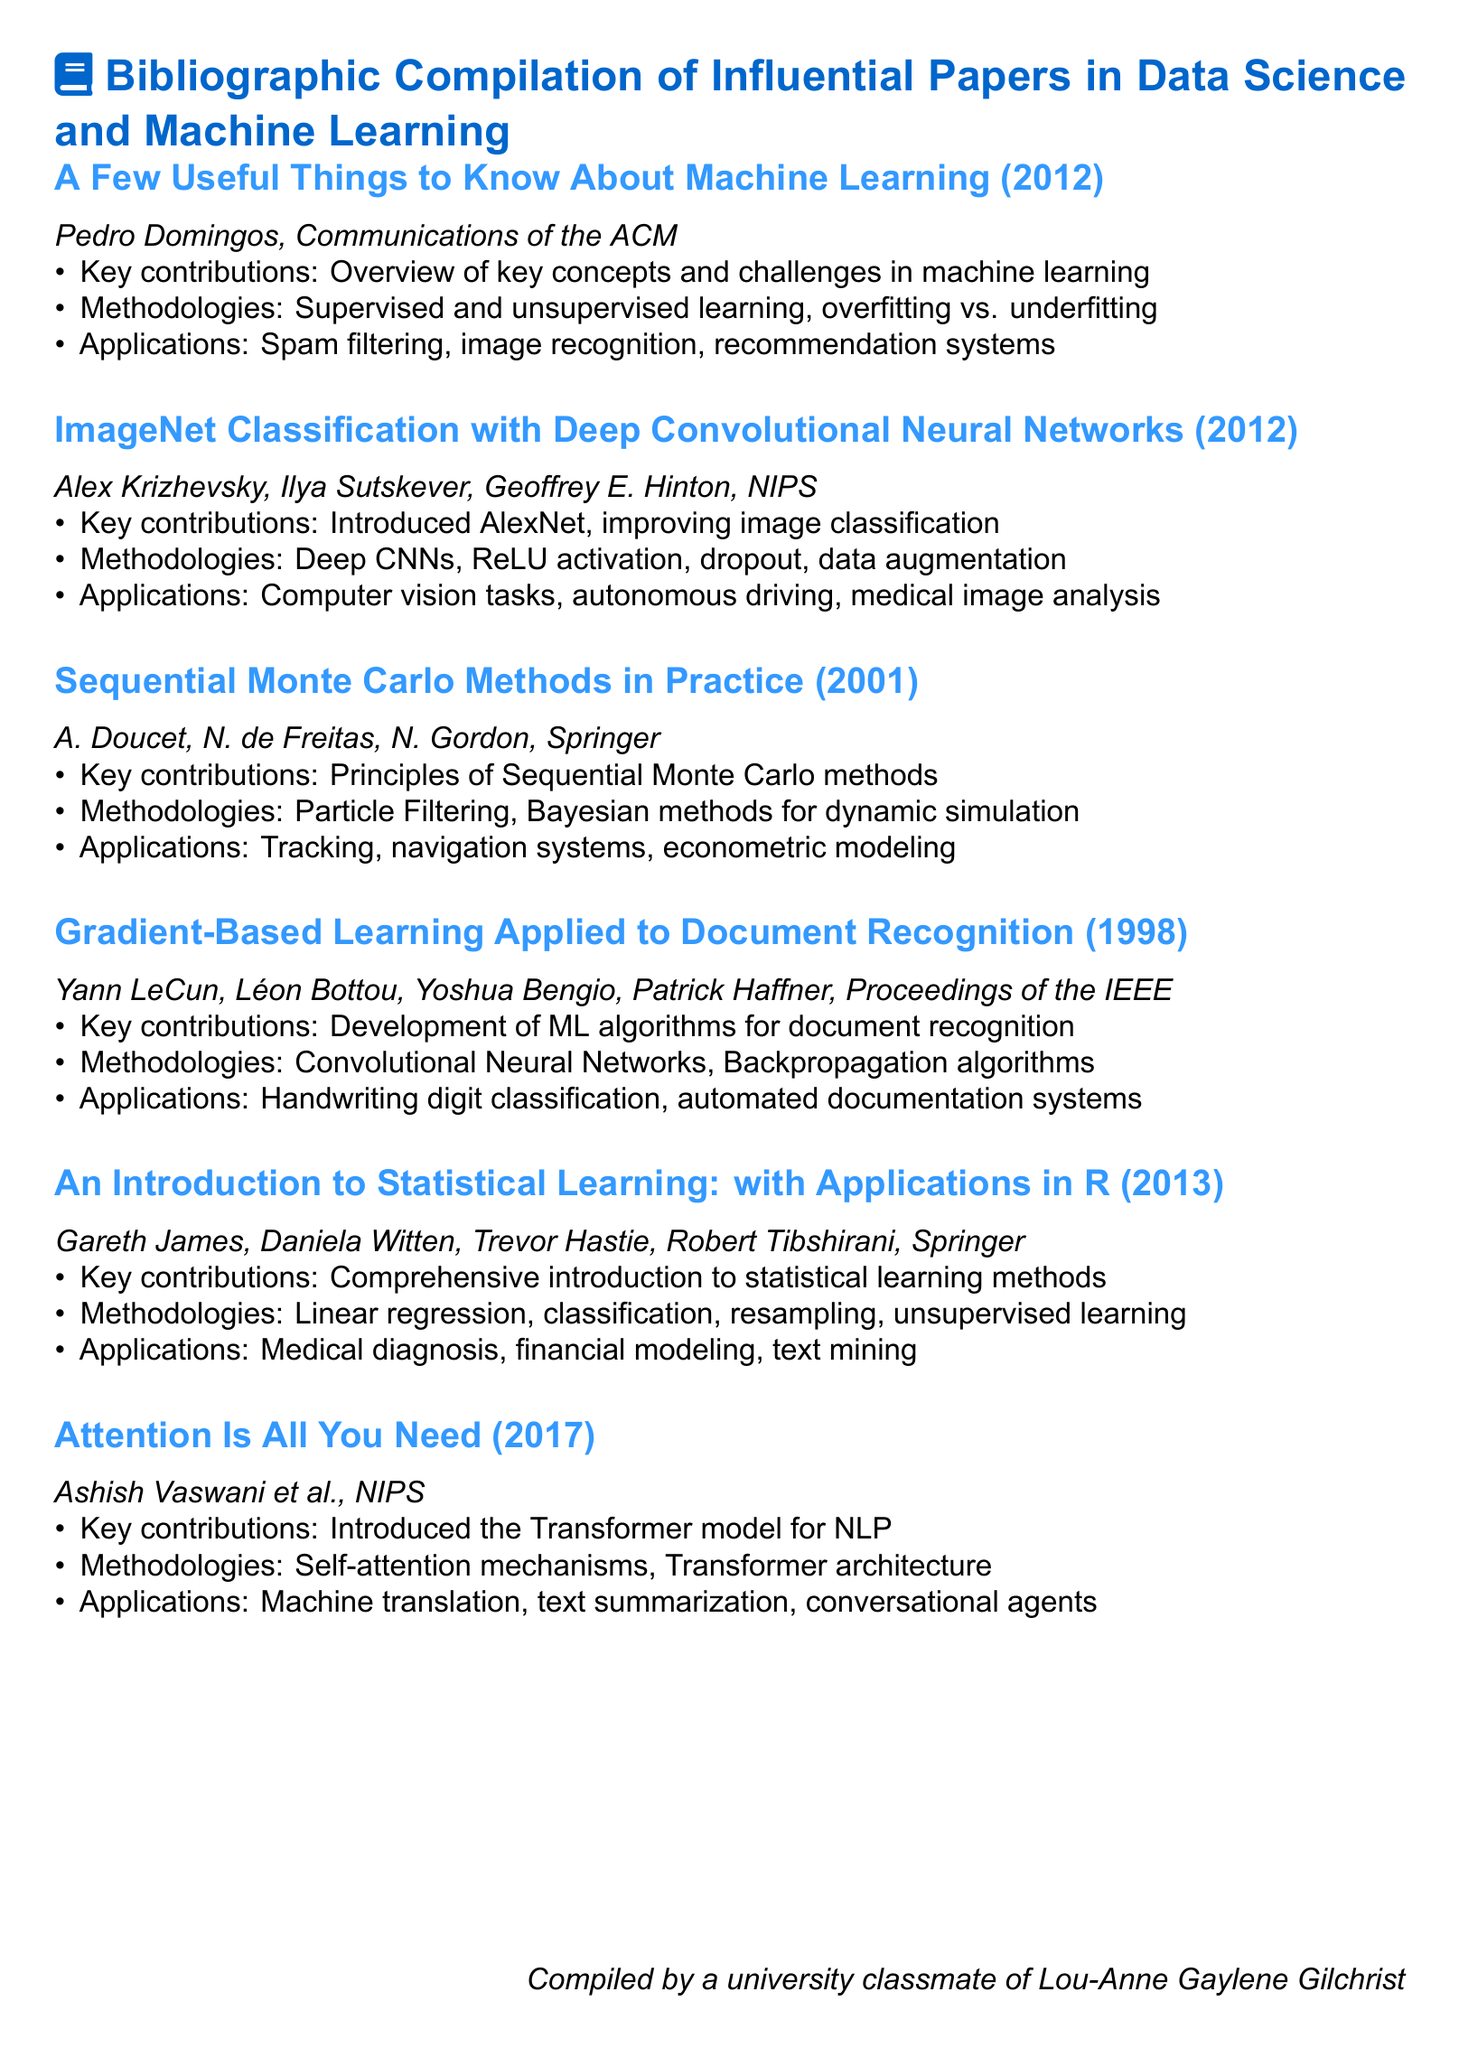What is the title of the document? The title of the document is the main heading found at the top of the rendered document, summarizing its content.
Answer: Bibliographic Compilation of Influential Papers in Data Science and Machine Learning Who is the author of "A Few Useful Things to Know About Machine Learning"? This paper's author is listed in the details for that specific entry in the document.
Answer: Pedro Domingos In which year was "Attention Is All You Need" published? The year of publication is provided directly in the details for that specific entry within the document.
Answer: 2017 What key contribution is mentioned for "ImageNet Classification with Deep Convolutional Neural Networks"? The particular contribution is highlighted in the respective section outlining this paper's impact in the field.
Answer: Introduced AlexNet, improving image classification Which methodologies are outlined for "An Introduction to Statistical Learning: with Applications in R"? The methodologies are identified in the bullet points under the corresponding paper entry in the document.
Answer: Linear regression, classification, resampling, unsupervised learning What application area is associated with "Sequential Monte Carlo Methods in Practice"? This area is specified under the application section for this particular paper in the document.
Answer: Tracking, navigation systems, econometric modeling What unique aspect does this document type present? This document specifically compiles influential papers along with their contributions, methodologies, and applications.
Answer: Bibliography How many authors contributed to "Gradient-Based Learning Applied to Document Recognition"? The number of authors is counted based on the names provided in the entry for this paper.
Answer: Four 